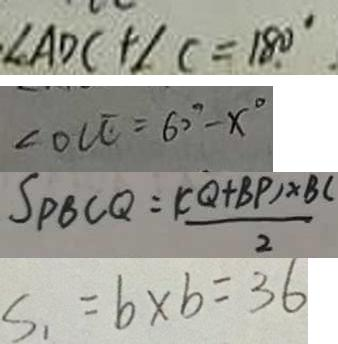<formula> <loc_0><loc_0><loc_500><loc_500>\angle A D C + \angle C = 1 8 0 ^ { \circ } 
 \angle O C E = 6 0 ^ { \circ } - x ^ { \circ } 
 S _ { P B C Q } = \frac { ( C Q + B P ) \times B C } { 2 } 
 S _ { 1 } = b \times b = 3 6</formula> 